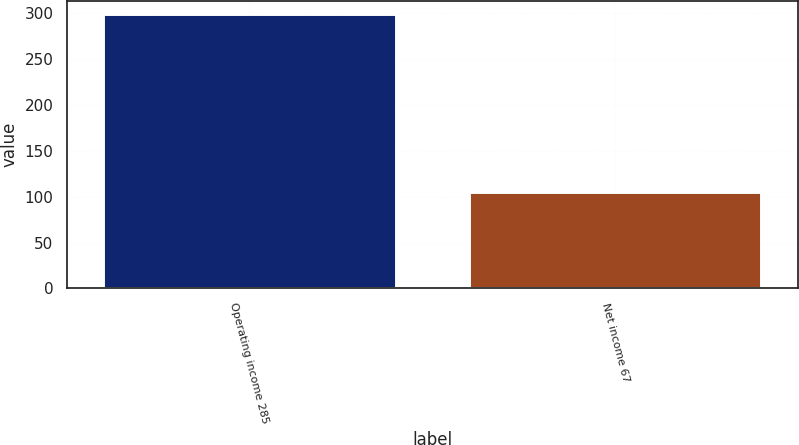Convert chart. <chart><loc_0><loc_0><loc_500><loc_500><bar_chart><fcel>Operating income 285<fcel>Net income 67<nl><fcel>299<fcel>105<nl></chart> 